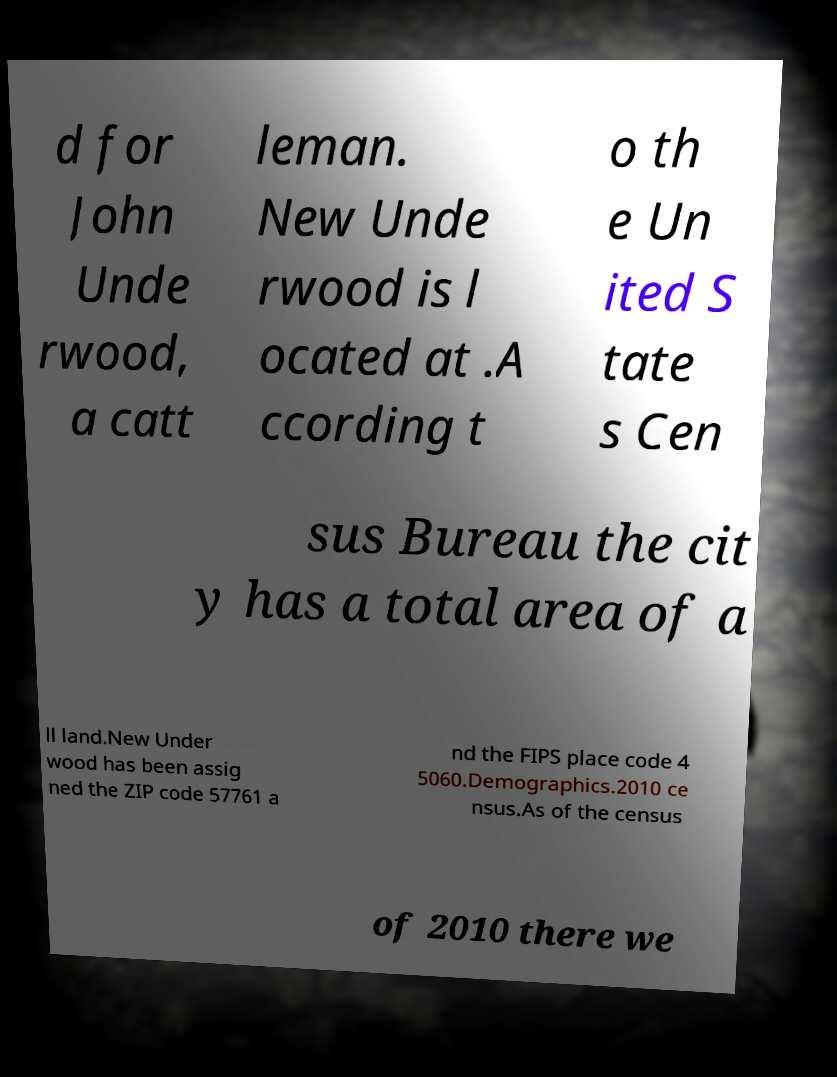Can you read and provide the text displayed in the image?This photo seems to have some interesting text. Can you extract and type it out for me? d for John Unde rwood, a catt leman. New Unde rwood is l ocated at .A ccording t o th e Un ited S tate s Cen sus Bureau the cit y has a total area of a ll land.New Under wood has been assig ned the ZIP code 57761 a nd the FIPS place code 4 5060.Demographics.2010 ce nsus.As of the census of 2010 there we 